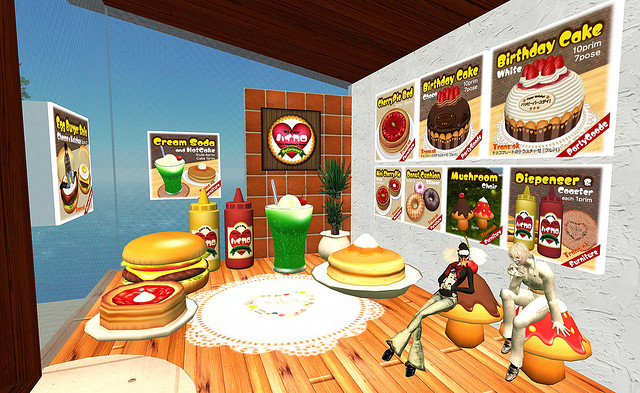Read all the text in this image. Birthday coke Birthday Cake White 10prim 7pos Mushroom Chair Tranrek 1pnm Cooeter Mushroom Tranrek Tranrek Soda Cream 